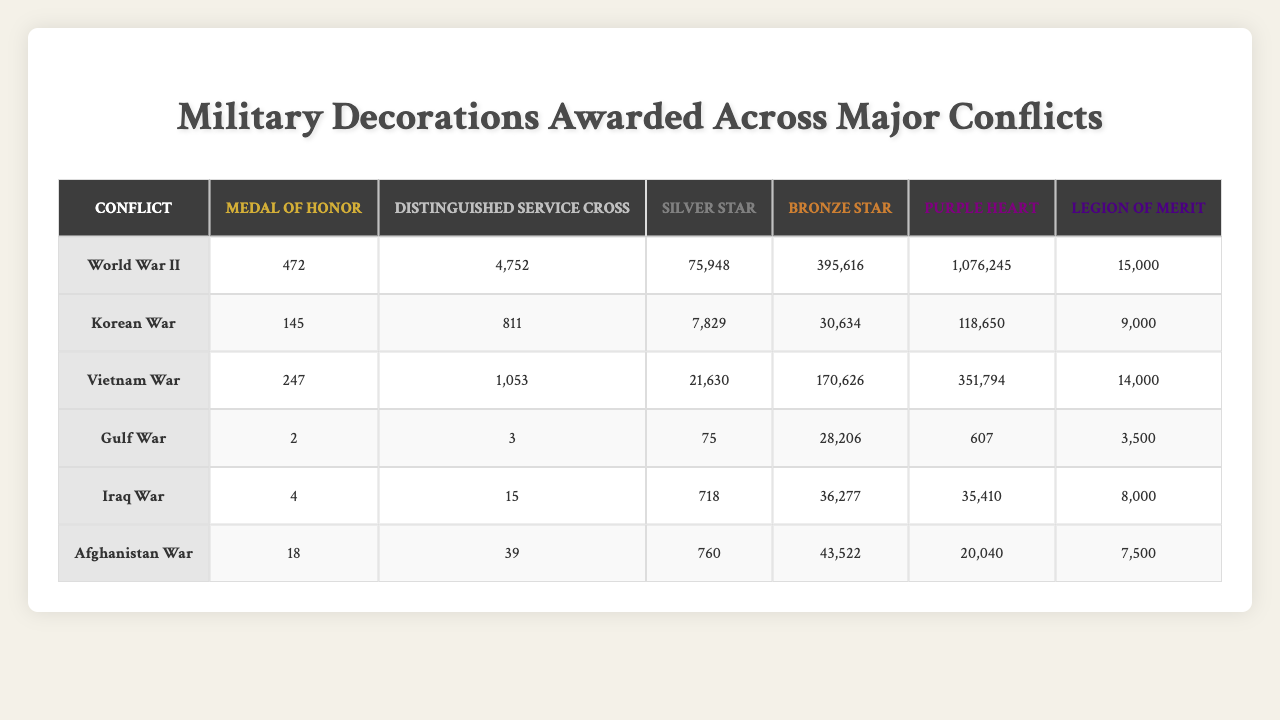What is the highest number of Purple Hearts awarded in a single conflict? Looking at the table, the highest number of Purple Hearts awarded is in World War II with 1,076,245.
Answer: 1,076,245 In which conflict was the least number of Medals of Honor awarded? The table shows that the Gulf War had the least number of Medals of Honor awarded with a total of 2.
Answer: 2 How many Distinguished Service Crosses were awarded in the Vietnam War? According to the table, the Vietnam War had 1,053 Distinguished Service Crosses awarded.
Answer: 1,053 Which conflict had the fewest total decorations awarded (sum of all awards)? To find this, we sum all the decorations for each conflict. The Gulf War has the lowest total with 28,224 decorations (2 + 3 + 75 + 28,206 + 607 + 3,500).
Answer: Gulf War Is it true that more Bronze Stars were awarded in the Iraq War than in the Afghanistan War? Comparing the numbers, Iraq War had 36,277 Bronze Stars, while Afghanistan War had 43,522. Therefore, it is false.
Answer: False What is the total number of Silver Stars awarded across all conflicts? The totals for Silver Stars in each conflict are summed up: 75,948 (WWII) + 7,829 (Korean) + 21,630 (Vietnam) + 75 (Gulf) + 718 (Iraq) + 760 (Afghanistan) = 106,060.
Answer: 106,060 Which conflict had the highest number of Legions of Merit? The table indicates the highest number of Legions of Merit was awarded during World War II, totaling 15,000.
Answer: 15,000 If we compare the total number of Medals of Honor awarded in World War II and the Korean War, how many more were awarded in World War II? World War II had 472 Medals of Honor, while the Korean War had 145. The difference is 472 - 145 = 327 more in World War II.
Answer: 327 What percentage of the total Purple Hearts awarded in the Iraq War does the total number awarded in the Gulf War represent? First, we find the total Purple Hearts: 118,650 (Korean) + 351,794 (Vietnam) + 607 (Gulf) + 35,410 (Iraq) = 506,461. The Gulf War's share is 607/506,461 = 0.0012 or roughly 0.12%.
Answer: 0.12% What is the average number of Bronze Stars awarded per conflict? To find the average, we sum the Bronze Stars: 395,616 (WWII) + 30,634 (Korean) + 170,626 (Vietnam) + 28,206 (Gulf) + 36,277 (Iraq) + 43,522 (Afghanistan) = 704,881. Then divide by 6 conflicts: 704,881 / 6 = 117,480.17.
Answer: 117,480.17 